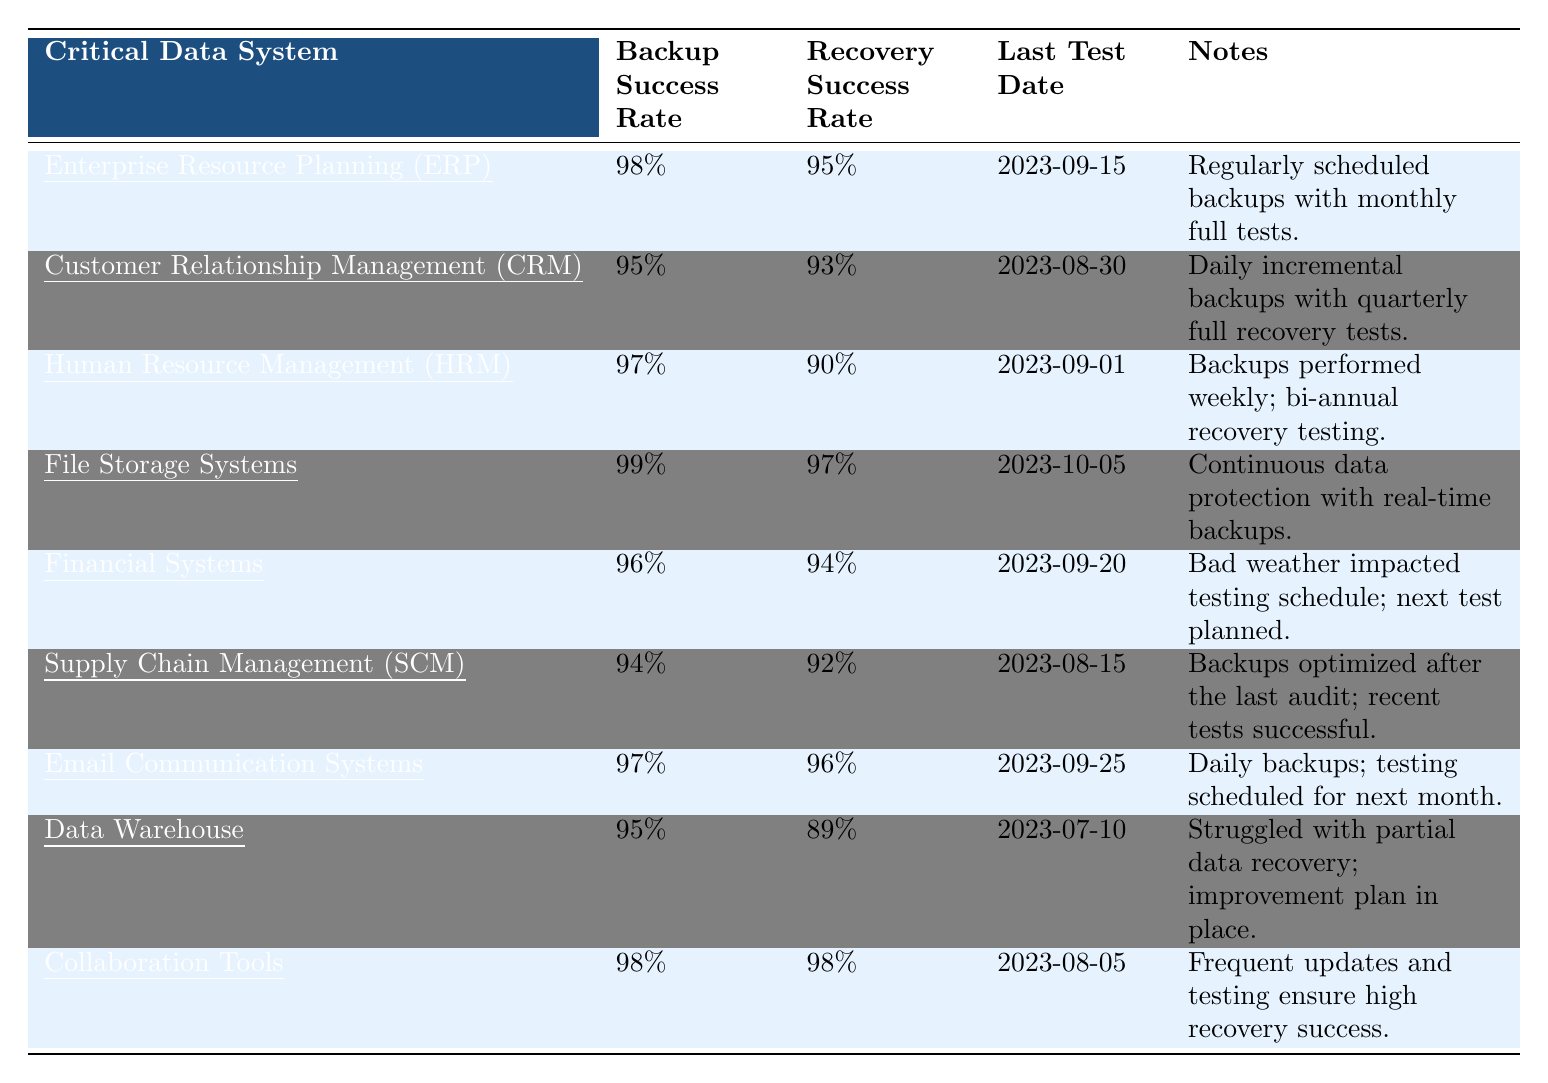What is the backup success rate for the File Storage Systems? The table shows that the backup success rate for File Storage Systems is directly listed as 99%.
Answer: 99% What is the last test date for the Human Resource Management system? Referring to the table, the last test date for Human Resource Management (HRM) is listed as 2023-09-01.
Answer: 2023-09-01 Which critical data system has the lowest recovery success rate? By comparing the recovery success rates, the Data Warehouse has the lowest recovery success rate listed at 89%.
Answer: Data Warehouse How many systems have a backup success rate of 95% or lower? The systems with a backup success rate of 95% or lower are Customer Relationship Management (CRM) at 95%, Supply Chain Management (SCM) at 94%, and Data Warehouse at 95%. Therefore, there are three such systems.
Answer: 3 Is the recovery success rate for the Collaboration Tools greater than the recovery success rate for Financial Systems? The recovery success rate for Collaboration Tools is 98%, while for Financial Systems it is 94%. Since 98% is greater than 94%, the statement is true.
Answer: Yes What is the average backup success rate of all the systems listed in the table? The backup success rates are 98%, 95%, 97%, 99%, 96%, 94%, 97%, 95%, and 98%, summing these gives  99 + 98 + 97 + 95 + 95 + 94 + 97 + 96 + 98 = 861. Since there are 9 systems, the average is 861/9 = 95.67%.
Answer: 95.67% Which system has the highest backup and recovery success rates? Comparing both backup and recovery success rates, File Storage Systems has the highest backup success rate at 99% and a high recovery success rate at 97%. Therefore, File Storage Systems has the highest overall success rates.
Answer: File Storage Systems Was the last test for Customer Relationship Management conducted more recently than that for Financial Systems? The last test for Customer Relationship Management was on 2023-08-30, and for Financial Systems, it was on 2023-09-20. Since 2023-09-20 is more recent than 2023-08-30, the answer is yes.
Answer: Yes What improvements are noted for the Data Warehouse based on its last test? According to the notes, the Data Warehouse struggled with partial data recovery, but there is an improvement plan in place.
Answer: Improvement plan in place What percentage difference exists between the highest and lowest recovery success rates among the listed systems? The highest recovery success rate is 98% (Collaboration Tools) and the lowest is 89% (Data Warehouse). The difference is 98% - 89% = 9%.
Answer: 9% 